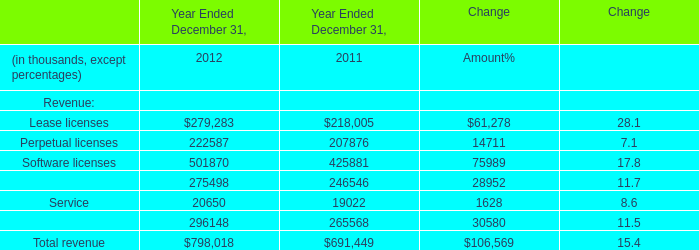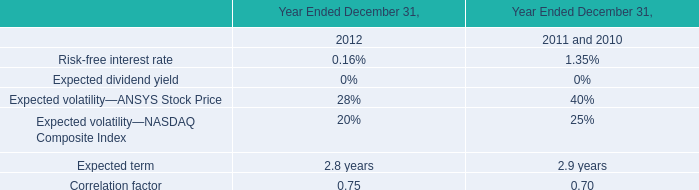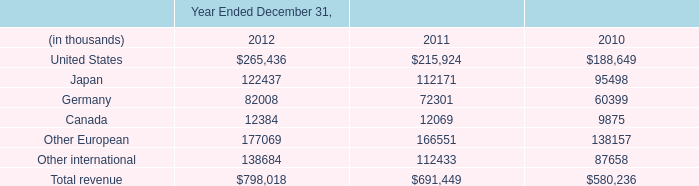what was the percentage change in the royalty fees are reported in cost of goods sold from 2011 to 2012 
Computations: ((9.3 - 8.4) + 8.4)
Answer: 9.3. 